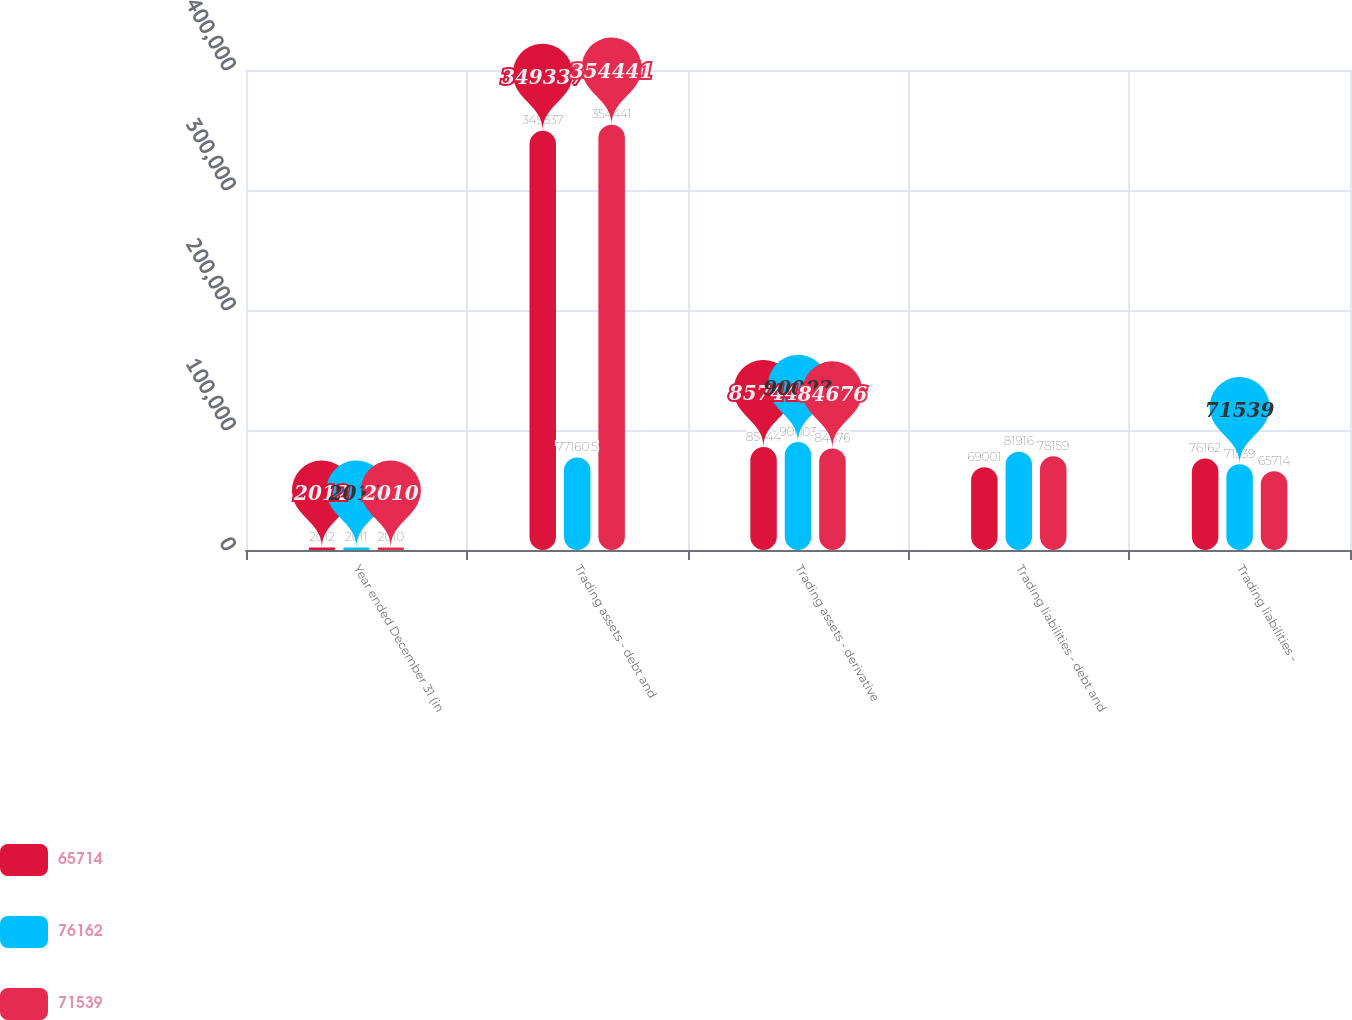<chart> <loc_0><loc_0><loc_500><loc_500><stacked_bar_chart><ecel><fcel>Year ended December 31 (in<fcel>Trading assets - debt and<fcel>Trading assets - derivative<fcel>Trading liabilities - debt and<fcel>Trading liabilities -<nl><fcel>65714<fcel>2012<fcel>349337<fcel>85744<fcel>69001<fcel>76162<nl><fcel>76162<fcel>2011<fcel>77160.5<fcel>90003<fcel>81916<fcel>71539<nl><fcel>71539<fcel>2010<fcel>354441<fcel>84676<fcel>78159<fcel>65714<nl></chart> 